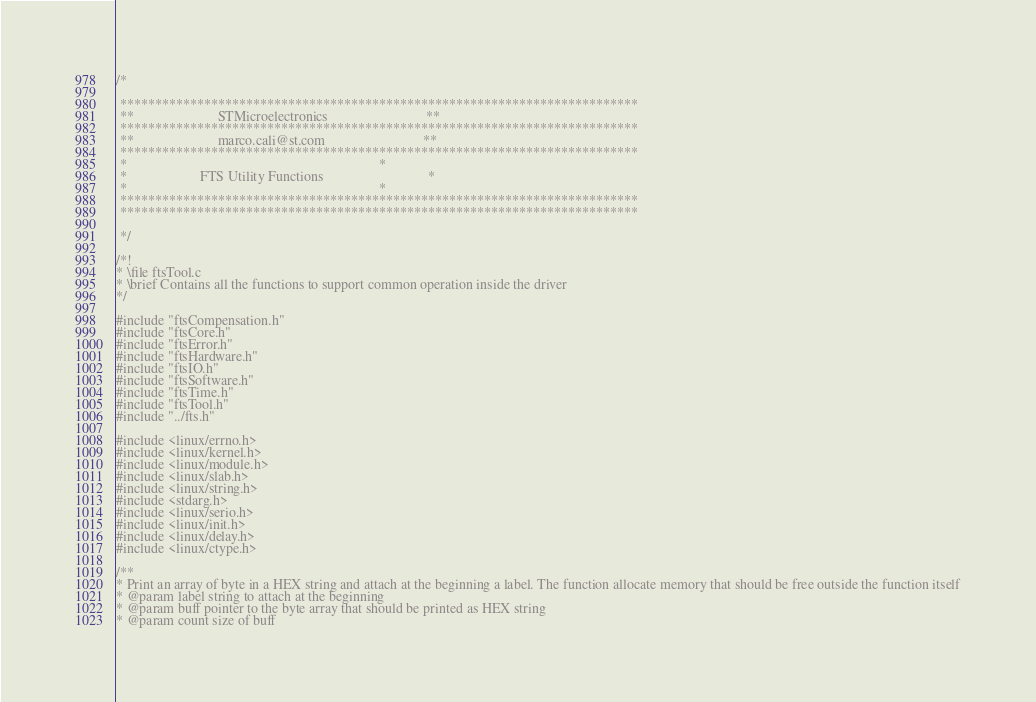<code> <loc_0><loc_0><loc_500><loc_500><_C_>/*

 **************************************************************************
 **                        STMicroelectronics							 **
 **************************************************************************
 **                        marco.cali@st.com							**
 **************************************************************************
 *                                                                        *
 *                     FTS Utility Functions							  *
 *                                                                        *
 **************************************************************************
 **************************************************************************

 */

/*!
* \file ftsTool.c
* \brief Contains all the functions to support common operation inside the driver
*/

#include "ftsCompensation.h"
#include "ftsCore.h"
#include "ftsError.h"
#include "ftsHardware.h"
#include "ftsIO.h"
#include "ftsSoftware.h"
#include "ftsTime.h"
#include "ftsTool.h"
#include "../fts.h"

#include <linux/errno.h>
#include <linux/kernel.h>
#include <linux/module.h>
#include <linux/slab.h>
#include <linux/string.h>
#include <stdarg.h>
#include <linux/serio.h>
#include <linux/init.h>
#include <linux/delay.h>
#include <linux/ctype.h>

/**
* Print an array of byte in a HEX string and attach at the beginning a label. The function allocate memory that should be free outside the function itself
* @param label string to attach at the beginning
* @param buff pointer to the byte array that should be printed as HEX string
* @param count size of buff</code> 